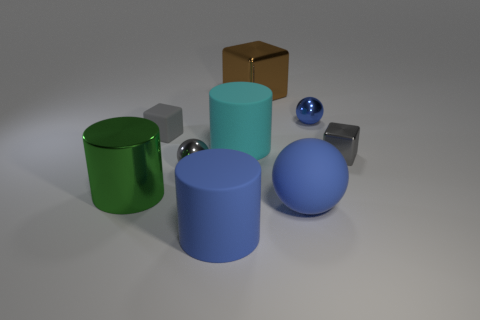What material is the ball that is the same color as the rubber cube?
Provide a succinct answer. Metal. Do the tiny rubber block and the small shiny block have the same color?
Offer a terse response. Yes. There is a brown object that is the same size as the cyan rubber thing; what is it made of?
Your response must be concise. Metal. Do the big brown cube and the large green thing have the same material?
Your response must be concise. Yes. What number of big green blocks have the same material as the tiny blue ball?
Your response must be concise. 0. What number of objects are either metal spheres to the right of the tiny gray metallic sphere or small gray metallic things that are to the right of the big metal block?
Offer a very short reply. 2. Are there more large rubber cylinders that are in front of the big metallic cylinder than blue rubber cylinders that are behind the small gray matte block?
Ensure brevity in your answer.  Yes. What color is the tiny metallic sphere right of the large blue sphere?
Keep it short and to the point. Blue. Are there any cyan objects that have the same shape as the green object?
Give a very brief answer. Yes. What number of gray things are small shiny cylinders or small metal things?
Your answer should be very brief. 2. 